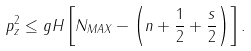<formula> <loc_0><loc_0><loc_500><loc_500>p _ { z } ^ { 2 } \leq g H \left [ N _ { M A X } - \left ( n + \frac { 1 } { 2 } + \frac { s } { 2 } \right ) \right ] .</formula> 